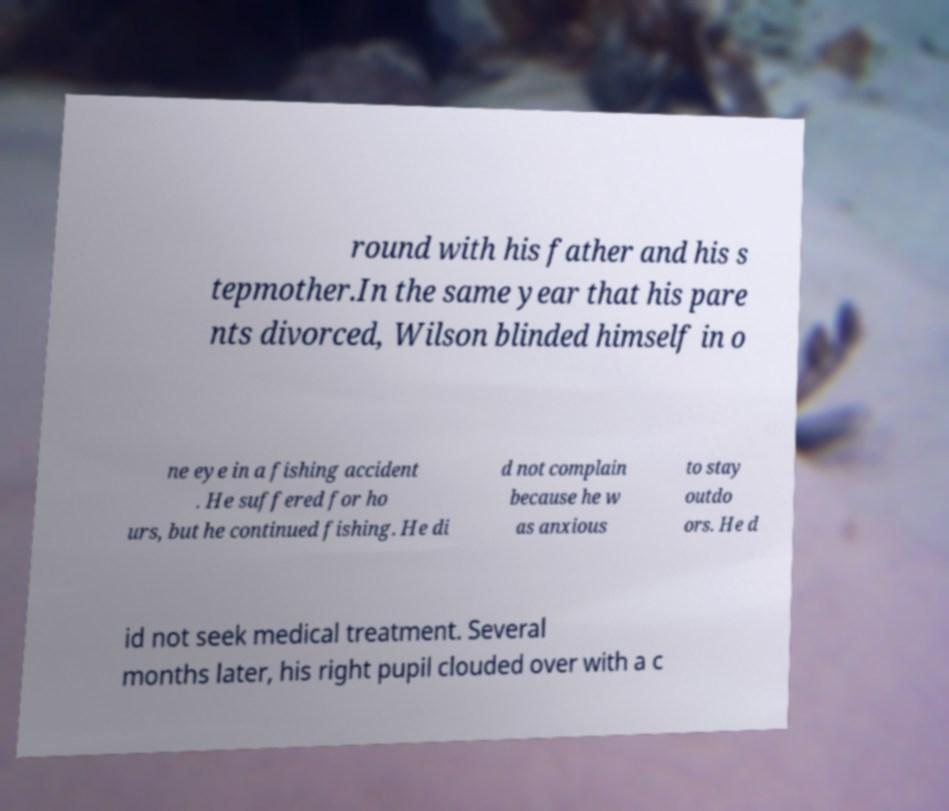Can you accurately transcribe the text from the provided image for me? round with his father and his s tepmother.In the same year that his pare nts divorced, Wilson blinded himself in o ne eye in a fishing accident . He suffered for ho urs, but he continued fishing. He di d not complain because he w as anxious to stay outdo ors. He d id not seek medical treatment. Several months later, his right pupil clouded over with a c 